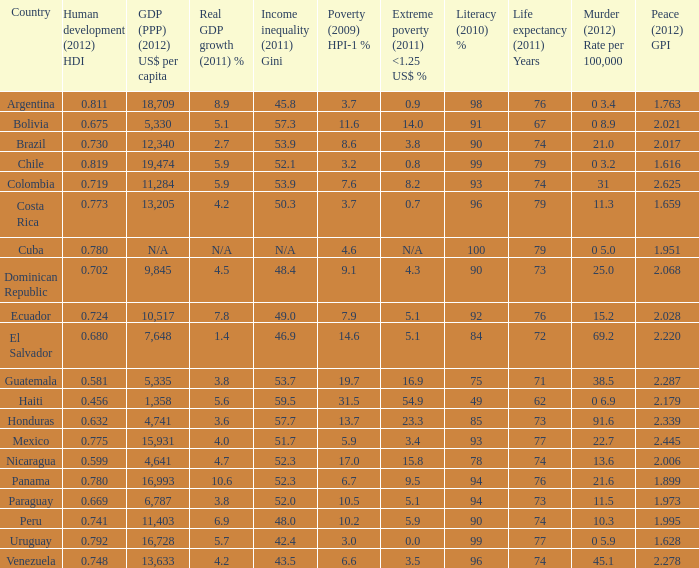What murder (2012) rate per 100,00 also has a 1.616 as the peace (2012) GPI? 0 3.2. 